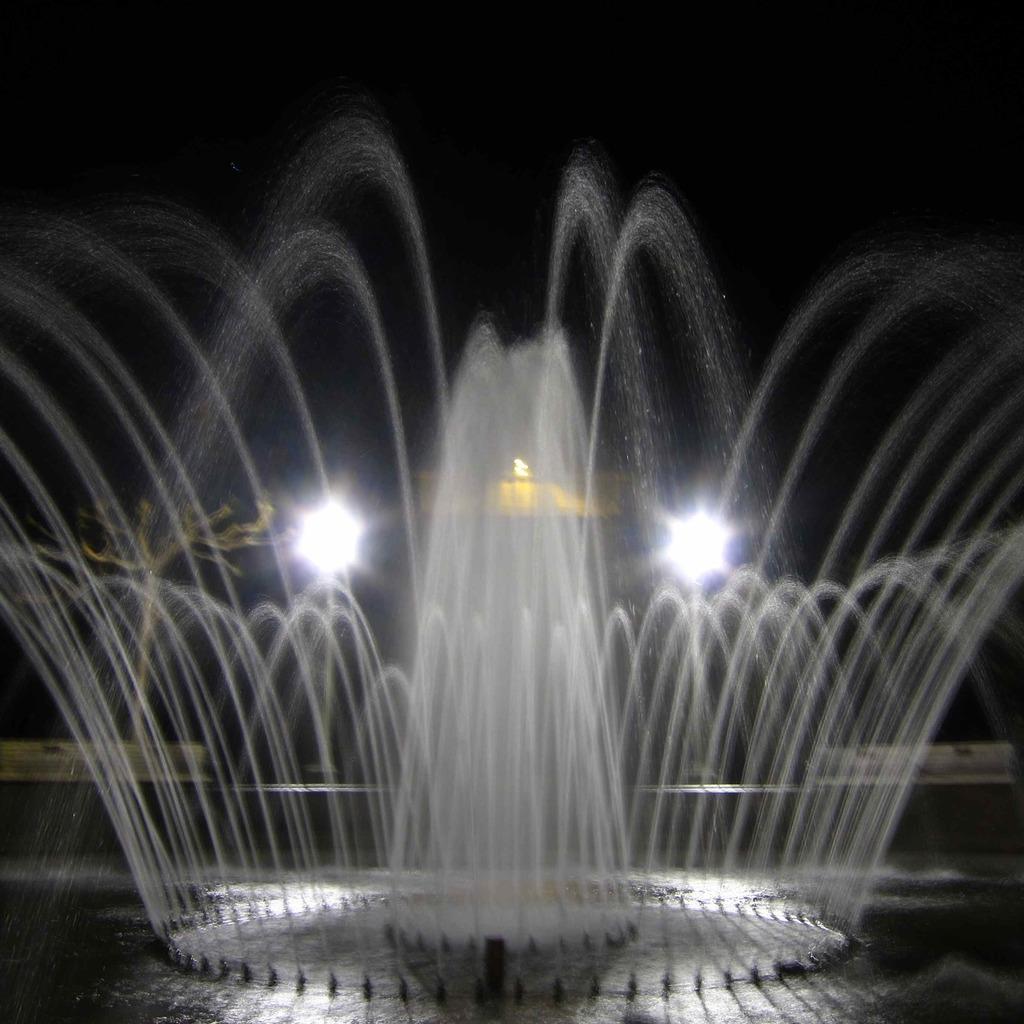Could you give a brief overview of what you see in this image? In this image I can see a fountain, background I can see two lights. 